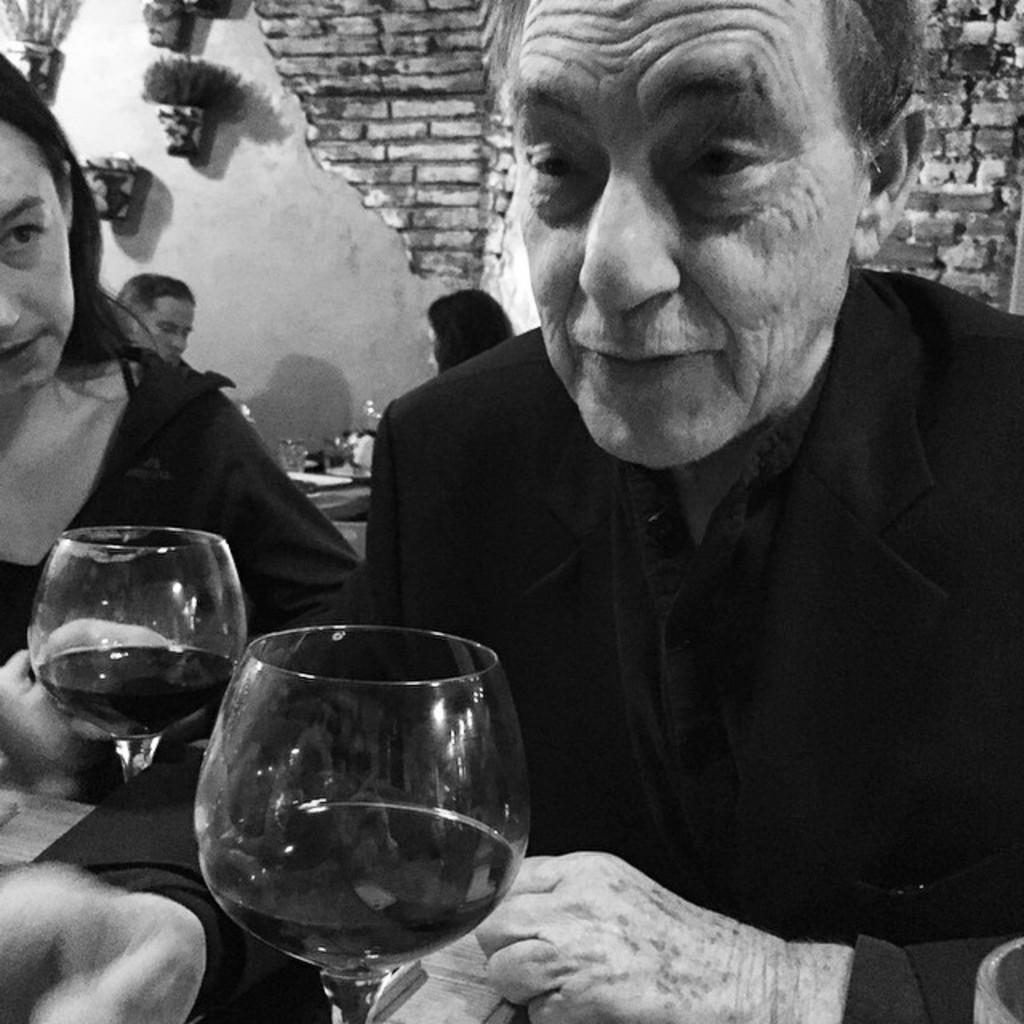Describe this image in one or two sentences. In this image there is a man and woman holding a wine glass and at the back ground there are some show plants attached to the wall, 2 persons sitting near the table. 